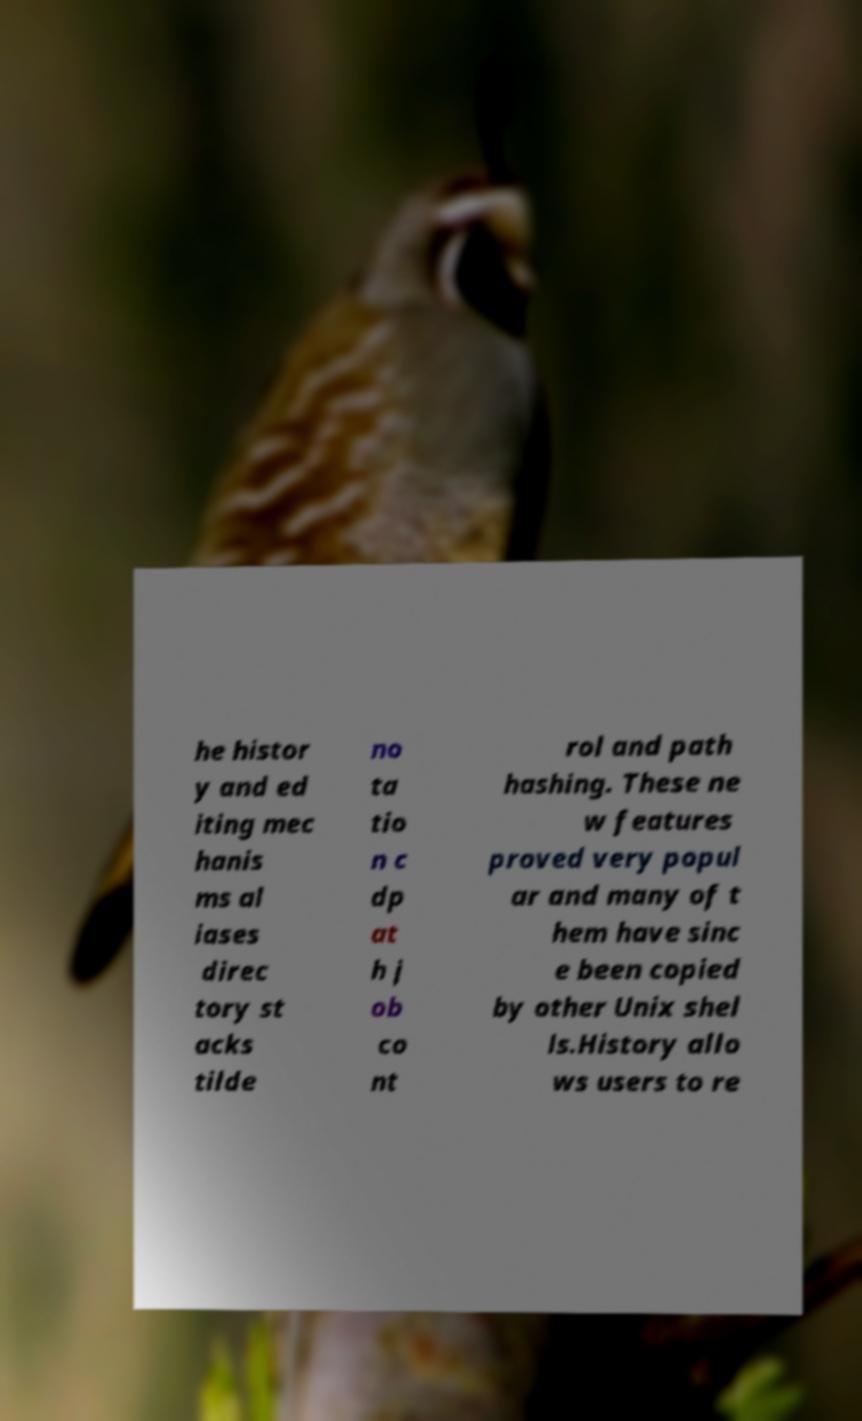Can you read and provide the text displayed in the image?This photo seems to have some interesting text. Can you extract and type it out for me? he histor y and ed iting mec hanis ms al iases direc tory st acks tilde no ta tio n c dp at h j ob co nt rol and path hashing. These ne w features proved very popul ar and many of t hem have sinc e been copied by other Unix shel ls.History allo ws users to re 